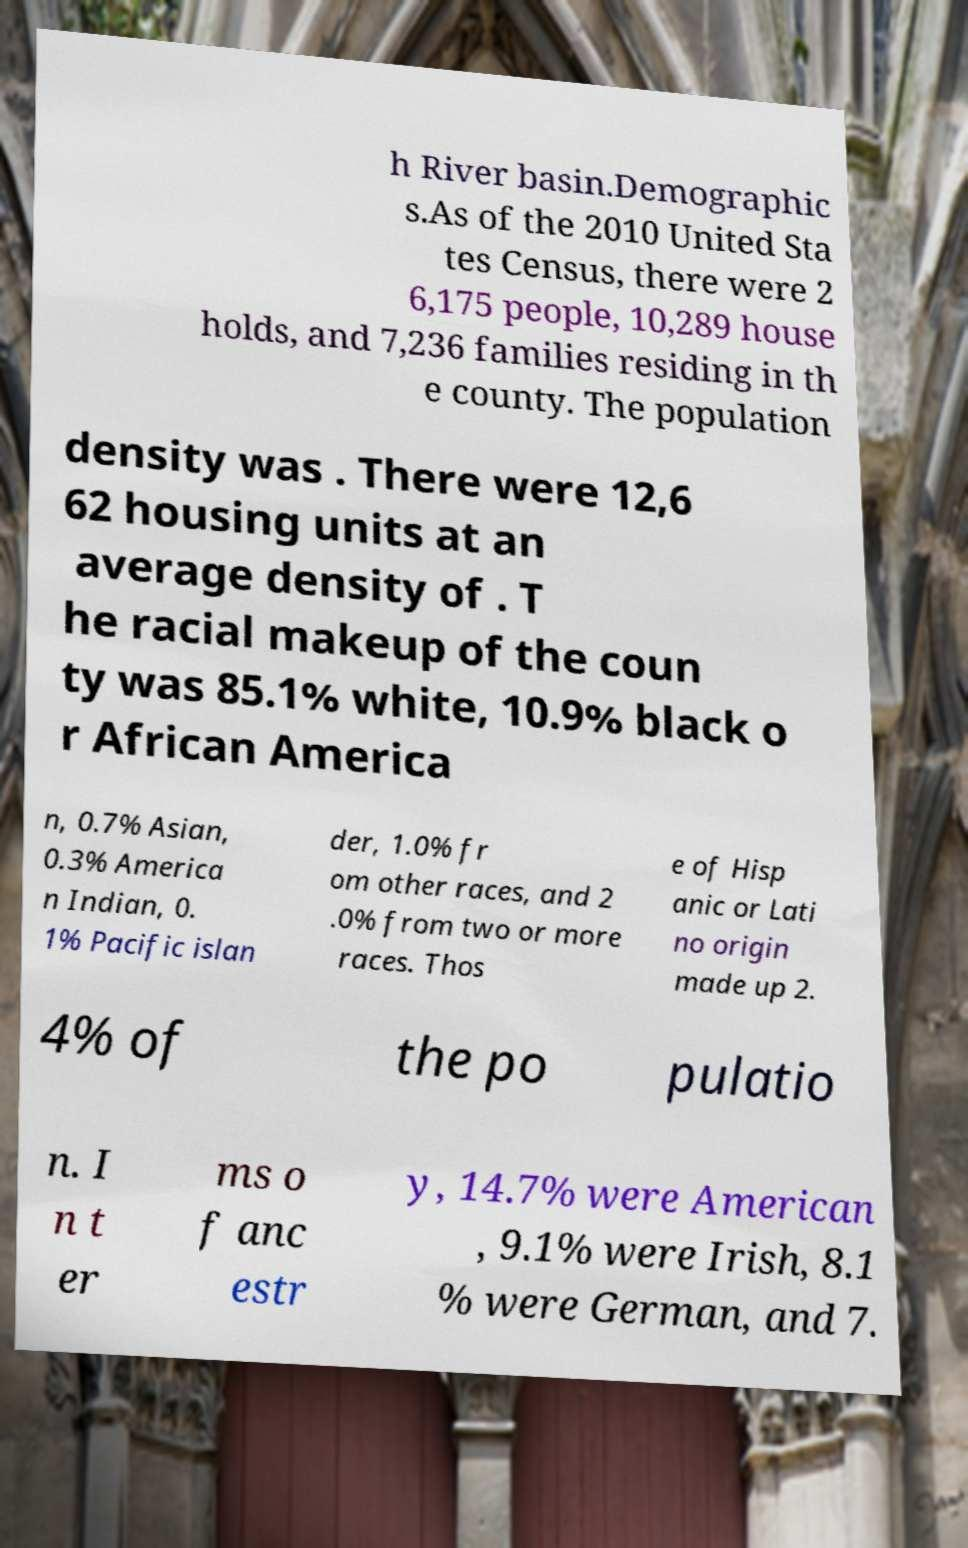Please read and relay the text visible in this image. What does it say? h River basin.Demographic s.As of the 2010 United Sta tes Census, there were 2 6,175 people, 10,289 house holds, and 7,236 families residing in th e county. The population density was . There were 12,6 62 housing units at an average density of . T he racial makeup of the coun ty was 85.1% white, 10.9% black o r African America n, 0.7% Asian, 0.3% America n Indian, 0. 1% Pacific islan der, 1.0% fr om other races, and 2 .0% from two or more races. Thos e of Hisp anic or Lati no origin made up 2. 4% of the po pulatio n. I n t er ms o f anc estr y, 14.7% were American , 9.1% were Irish, 8.1 % were German, and 7. 